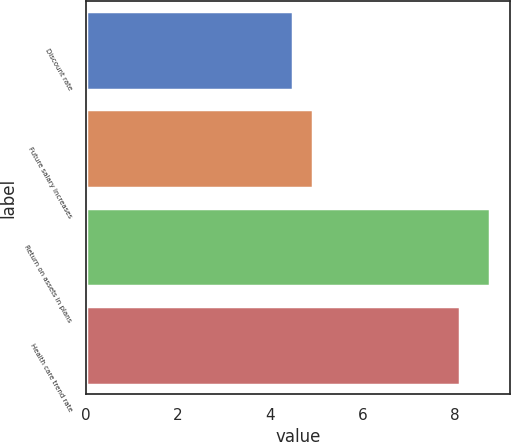Convert chart to OTSL. <chart><loc_0><loc_0><loc_500><loc_500><bar_chart><fcel>Discount rate<fcel>Future salary increases<fcel>Return on assets in plans<fcel>Health care trend rate<nl><fcel>4.5<fcel>4.92<fcel>8.75<fcel>8.1<nl></chart> 